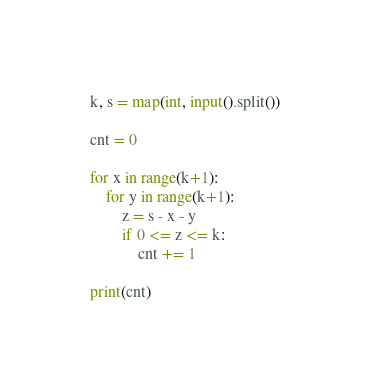Convert code to text. <code><loc_0><loc_0><loc_500><loc_500><_Python_>k, s = map(int, input().split())

cnt = 0

for x in range(k+1):
    for y in range(k+1):
        z = s - x - y
        if 0 <= z <= k:
            cnt += 1

print(cnt)
</code> 